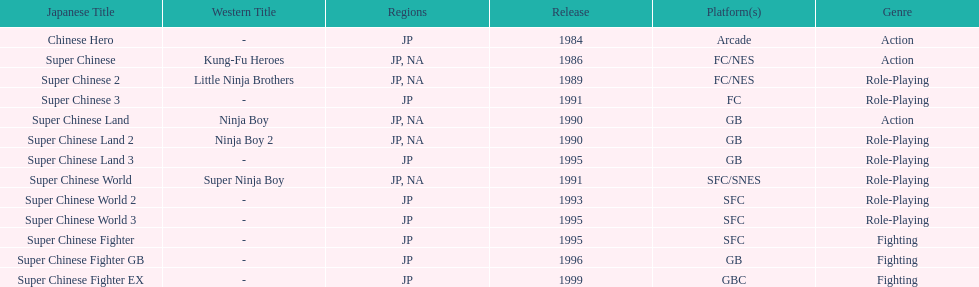Number of super chinese world games released 3. 